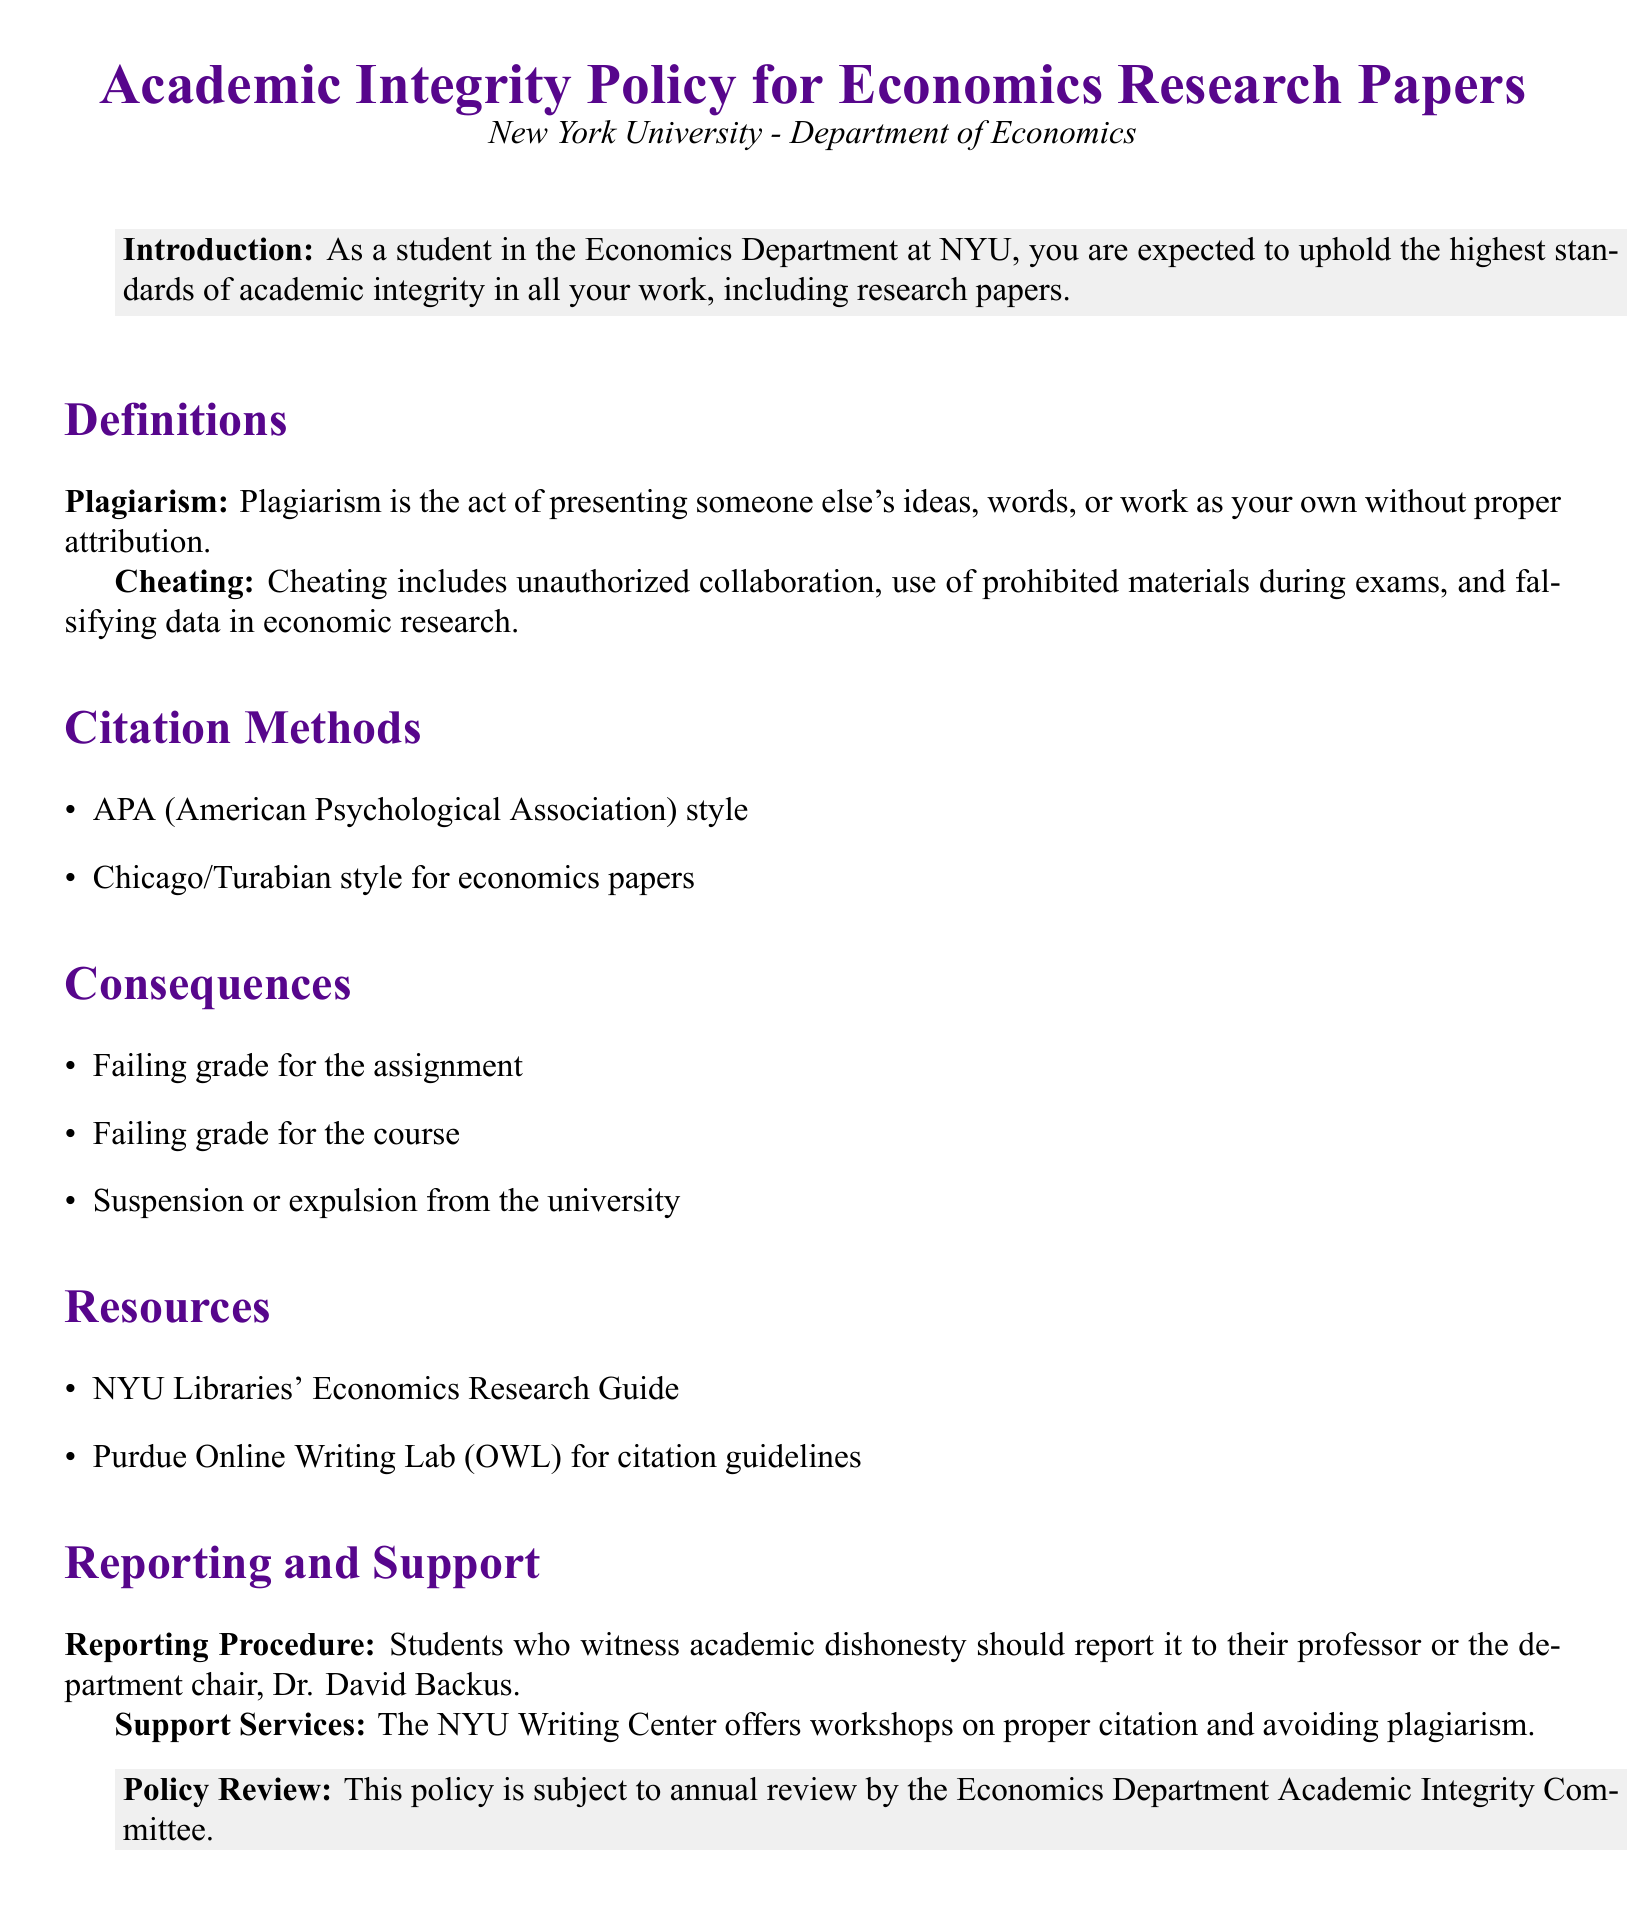What is the title of the document? The title appears at the top of the document and states the main focus of the policy.
Answer: Academic Integrity Policy for Economics Research Papers What is considered plagiarism? The definition of plagiarism is explicitly mentioned in the document under the Definitions section.
Answer: Presenting someone else's ideas, words, or work as your own without proper attribution Who should be notified of academic dishonesty? The document specifies the reporting procedure, indicating to whom students should report.
Answer: Their professor or the department chair, Dr. David Backus What are the consequences of cheating? The consequences are listed under a specific section in the document, outlining potential penalties.
Answer: Failing grade for the assignment What citation styles are recommended for economics papers? This information is provided under the Citation Methods section of the document.
Answer: APA and Chicago/Turabian styles 